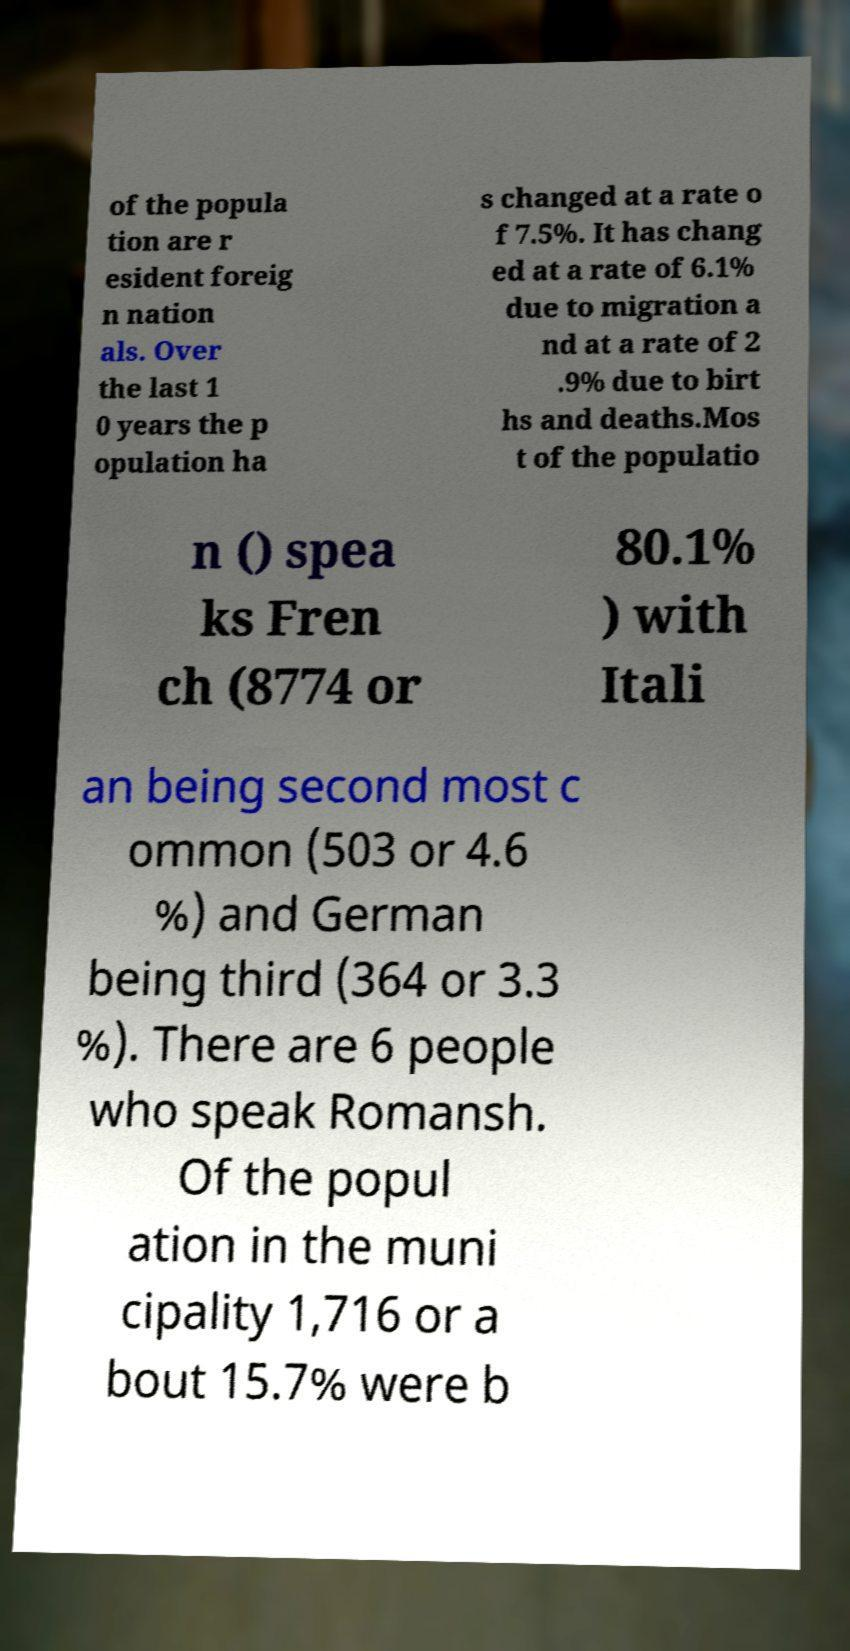Can you accurately transcribe the text from the provided image for me? of the popula tion are r esident foreig n nation als. Over the last 1 0 years the p opulation ha s changed at a rate o f 7.5%. It has chang ed at a rate of 6.1% due to migration a nd at a rate of 2 .9% due to birt hs and deaths.Mos t of the populatio n () spea ks Fren ch (8774 or 80.1% ) with Itali an being second most c ommon (503 or 4.6 %) and German being third (364 or 3.3 %). There are 6 people who speak Romansh. Of the popul ation in the muni cipality 1,716 or a bout 15.7% were b 